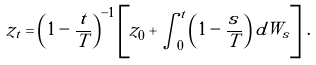Convert formula to latex. <formula><loc_0><loc_0><loc_500><loc_500>z _ { t } = \left ( 1 - \frac { t } { T } \right ) ^ { - 1 } \left [ z _ { 0 } + \int _ { 0 } ^ { t } \left ( 1 - \frac { s } { T } \right ) d W _ { s } \right ] \, .</formula> 